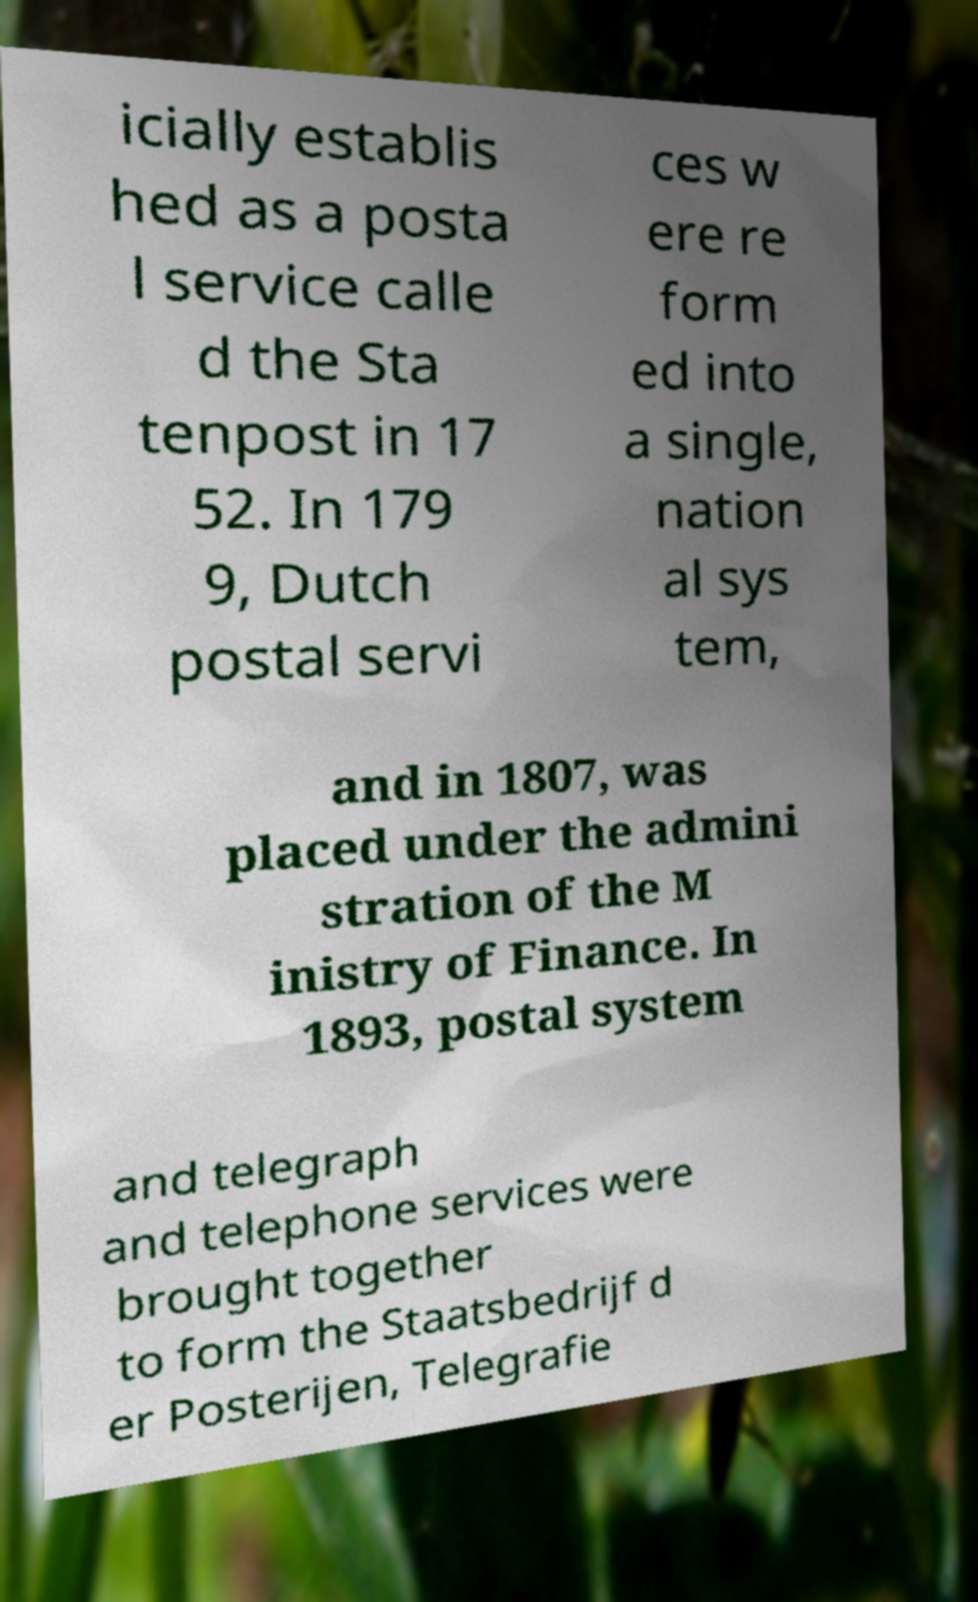I need the written content from this picture converted into text. Can you do that? icially establis hed as a posta l service calle d the Sta tenpost in 17 52. In 179 9, Dutch postal servi ces w ere re form ed into a single, nation al sys tem, and in 1807, was placed under the admini stration of the M inistry of Finance. In 1893, postal system and telegraph and telephone services were brought together to form the Staatsbedrijf d er Posterijen, Telegrafie 